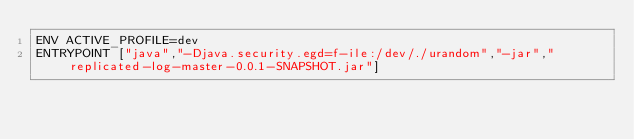<code> <loc_0><loc_0><loc_500><loc_500><_Dockerfile_>ENV ACTIVE_PROFILE=dev
ENTRYPOINT ["java","-Djava.security.egd=f-ile:/dev/./urandom","-jar","replicated-log-master-0.0.1-SNAPSHOT.jar"]</code> 